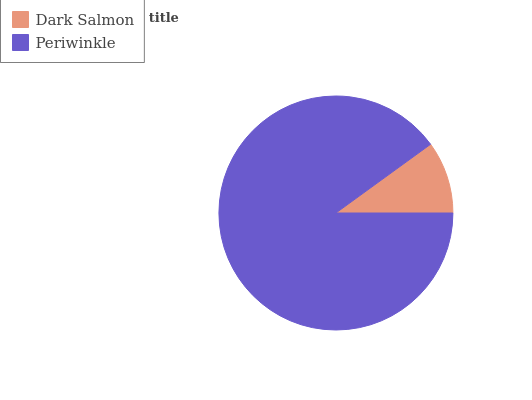Is Dark Salmon the minimum?
Answer yes or no. Yes. Is Periwinkle the maximum?
Answer yes or no. Yes. Is Periwinkle the minimum?
Answer yes or no. No. Is Periwinkle greater than Dark Salmon?
Answer yes or no. Yes. Is Dark Salmon less than Periwinkle?
Answer yes or no. Yes. Is Dark Salmon greater than Periwinkle?
Answer yes or no. No. Is Periwinkle less than Dark Salmon?
Answer yes or no. No. Is Periwinkle the high median?
Answer yes or no. Yes. Is Dark Salmon the low median?
Answer yes or no. Yes. Is Dark Salmon the high median?
Answer yes or no. No. Is Periwinkle the low median?
Answer yes or no. No. 